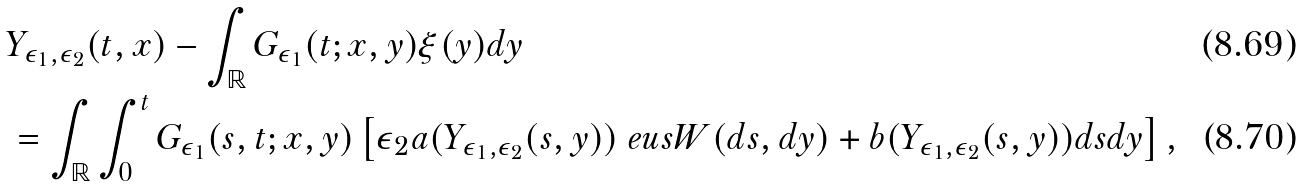<formula> <loc_0><loc_0><loc_500><loc_500>& Y _ { \epsilon _ { 1 } , \epsilon _ { 2 } } ( t , x ) - \int _ { \mathbb { R } } G _ { \epsilon _ { 1 } } ( t ; x , y ) \xi ( y ) d y \\ & = \int _ { \mathbb { R } } \int _ { 0 } ^ { t } G _ { \epsilon _ { 1 } } ( s , t ; x , y ) \left [ { \epsilon _ { 2 } a ( Y _ { \epsilon _ { 1 } , \epsilon _ { 2 } } ( s , y ) ) } \ e u s { W } ( d s , d y ) + b ( Y _ { \epsilon _ { 1 } , \epsilon _ { 2 } } ( s , y ) ) d s d y \right ] ,</formula> 